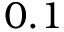Convert formula to latex. <formula><loc_0><loc_0><loc_500><loc_500>0 . 1</formula> 